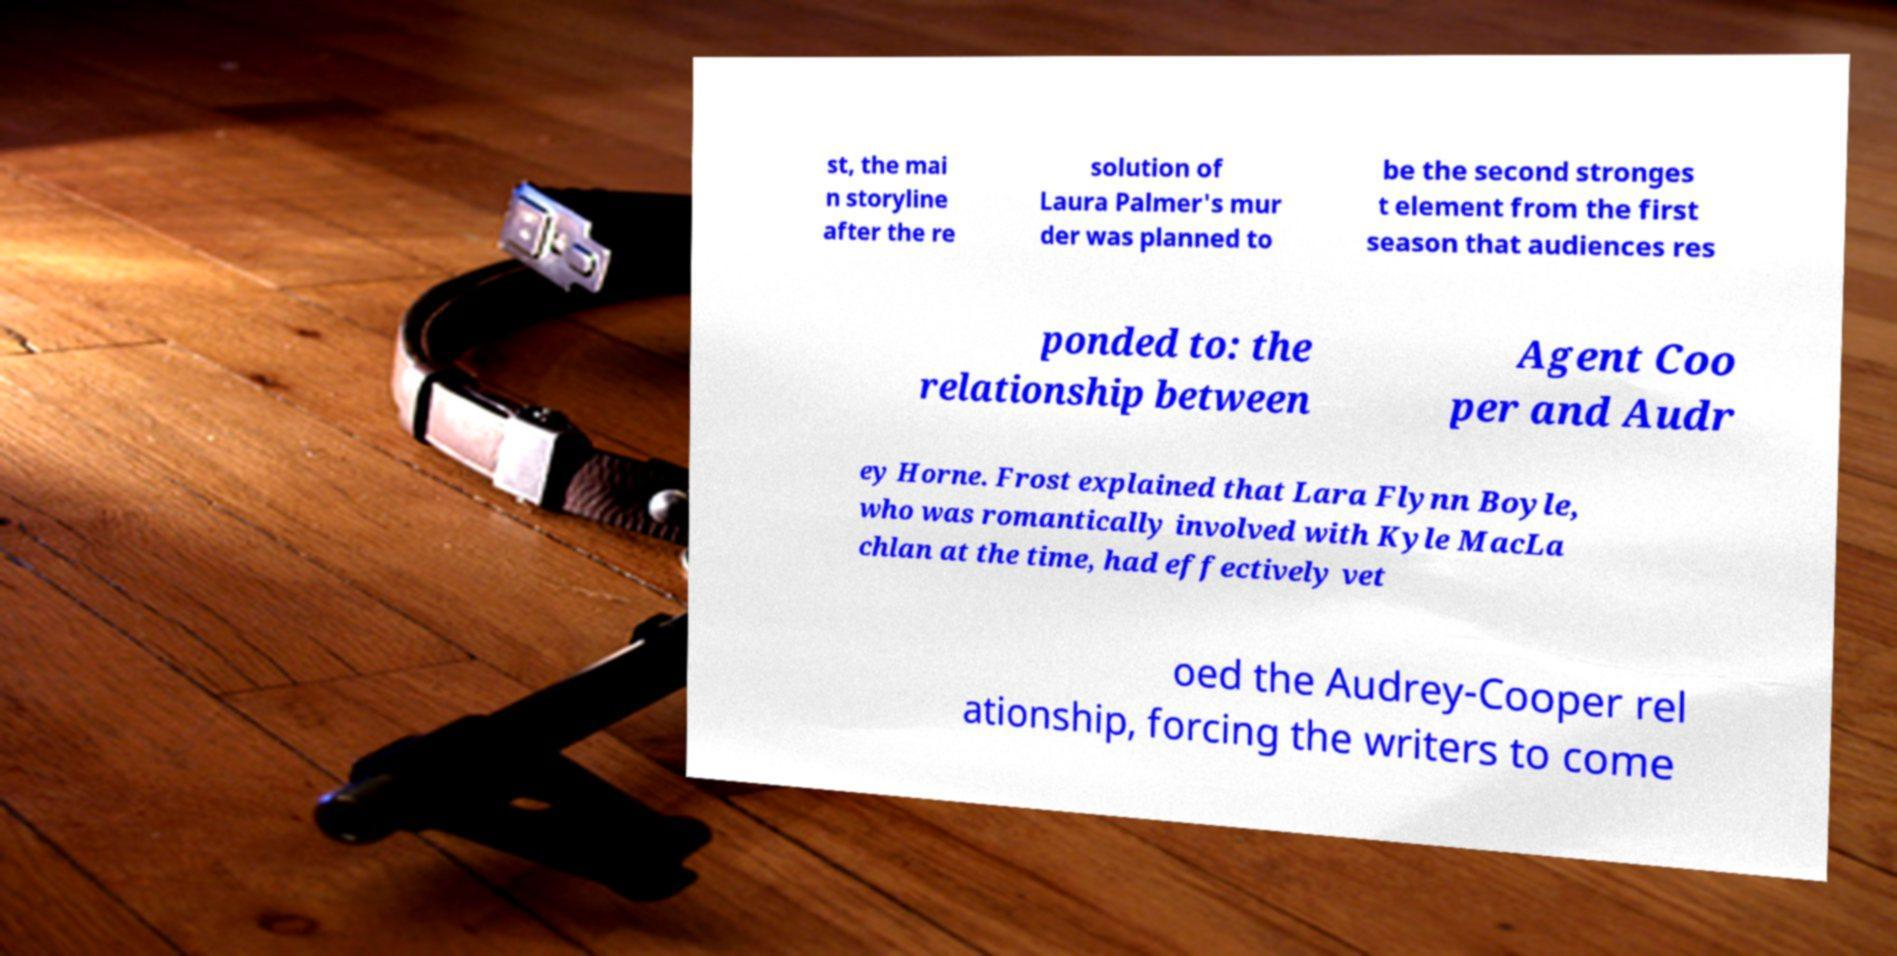I need the written content from this picture converted into text. Can you do that? st, the mai n storyline after the re solution of Laura Palmer's mur der was planned to be the second stronges t element from the first season that audiences res ponded to: the relationship between Agent Coo per and Audr ey Horne. Frost explained that Lara Flynn Boyle, who was romantically involved with Kyle MacLa chlan at the time, had effectively vet oed the Audrey-Cooper rel ationship, forcing the writers to come 